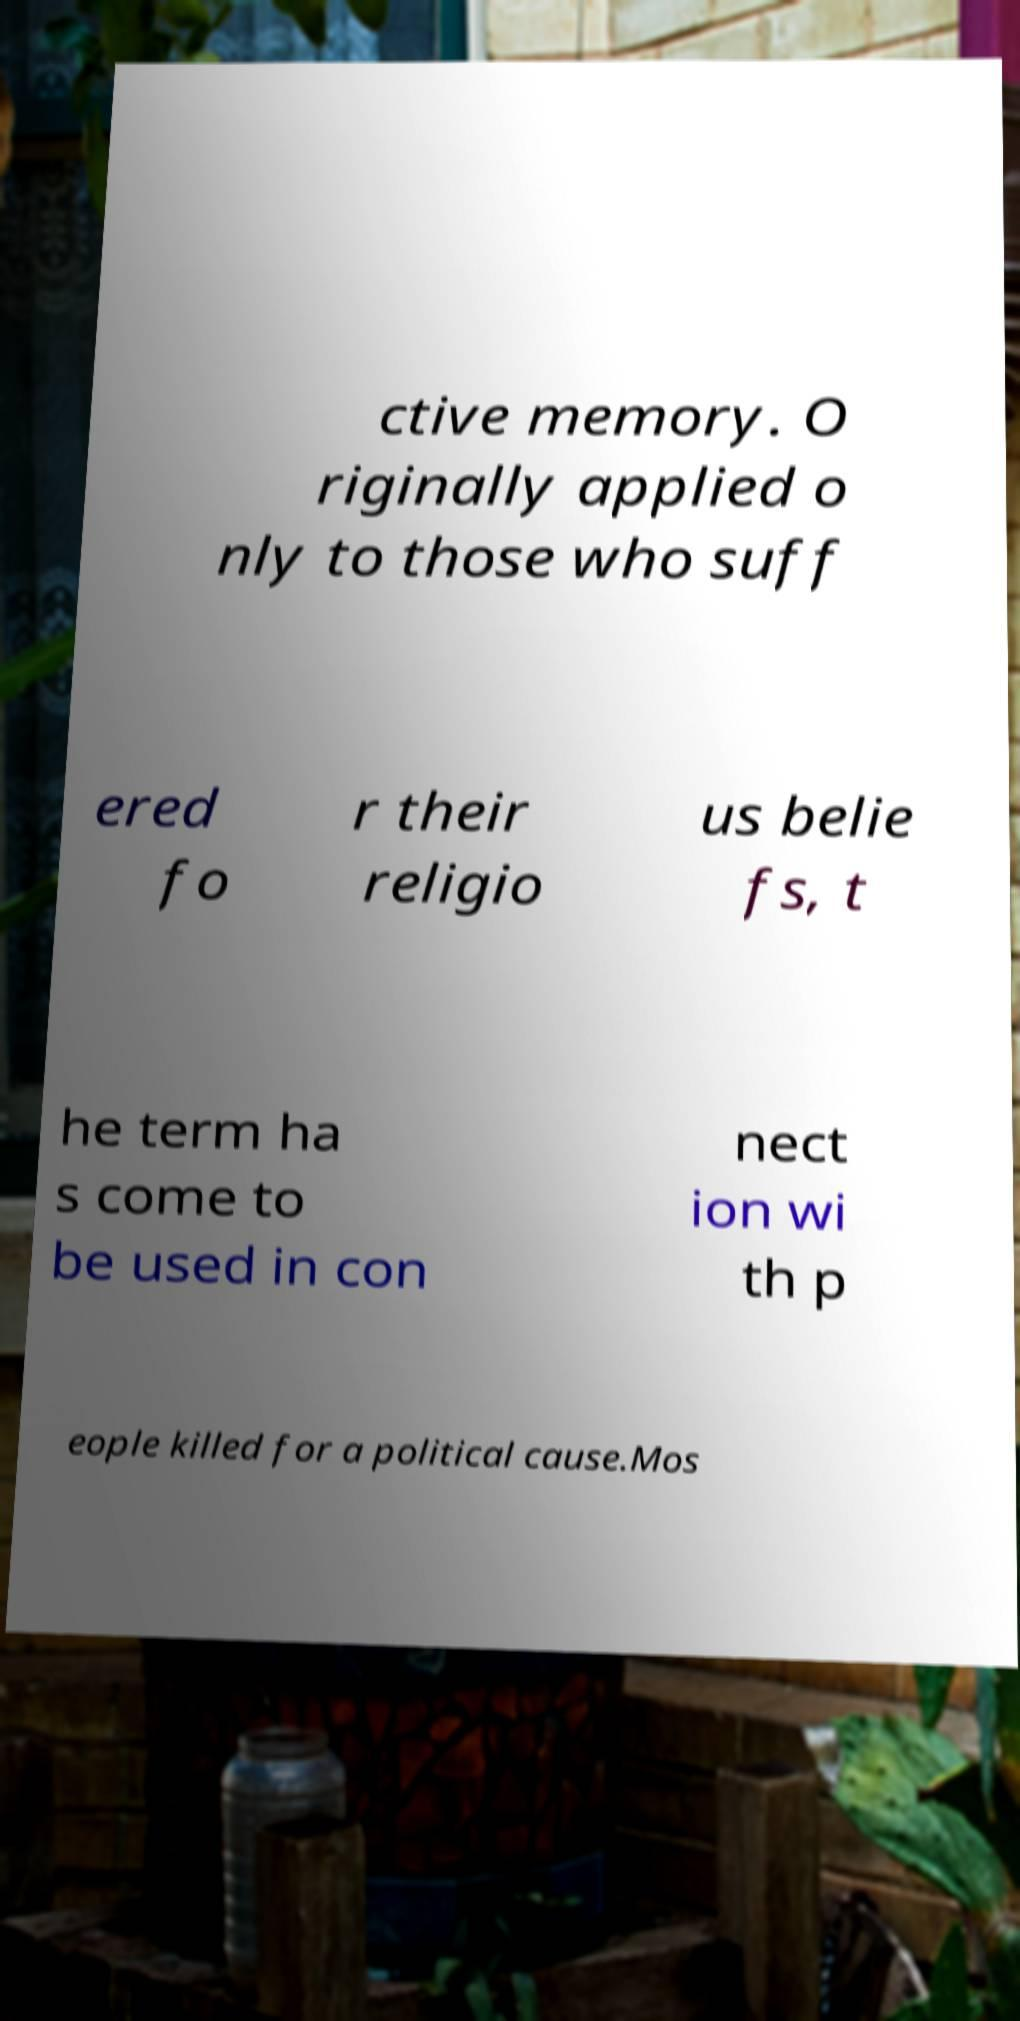There's text embedded in this image that I need extracted. Can you transcribe it verbatim? ctive memory. O riginally applied o nly to those who suff ered fo r their religio us belie fs, t he term ha s come to be used in con nect ion wi th p eople killed for a political cause.Mos 